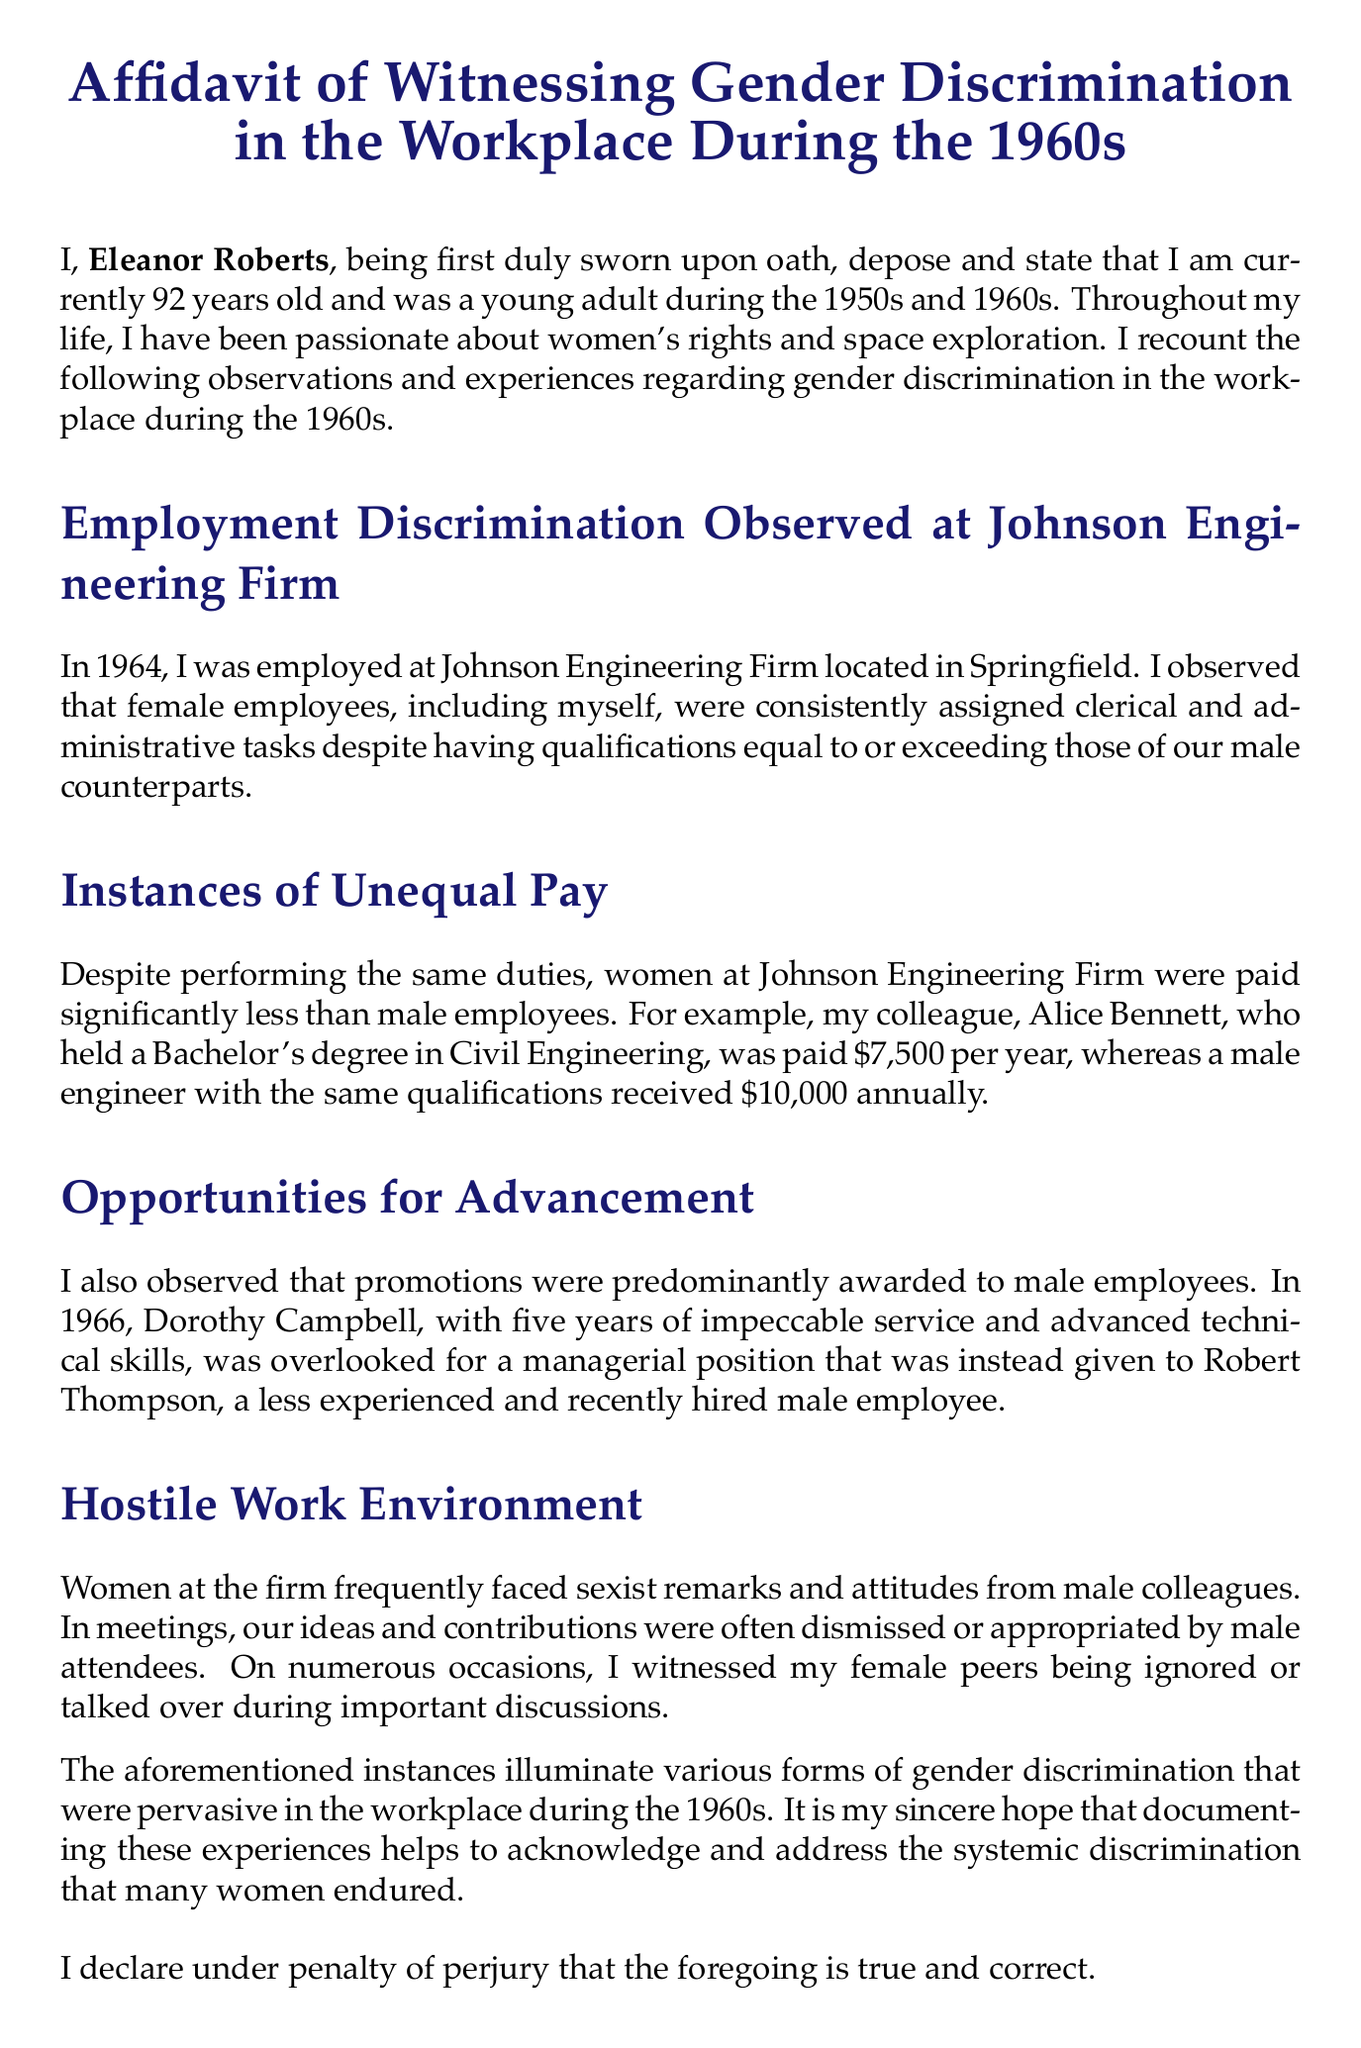what is the name of the witness? The document states the name of the witness is Eleanor Roberts.
Answer: Eleanor Roberts what year did Eleanor Roberts observe employment discrimination? The document mentions that employment discrimination was observed in 1964.
Answer: 1964 how much was Alice Bennett's salary per year? The document specifies that Alice Bennett was paid $7,500 per year.
Answer: $7,500 who was overlooked for the managerial position? The document states that Dorothy Campbell was overlooked for the managerial position.
Answer: Dorothy Campbell how many years of service did Dorothy Campbell have? The document indicates that Dorothy Campbell had five years of service.
Answer: five years what was the salary of the male engineer with equal qualifications? The document mentions that the male engineer received $10,000 annually.
Answer: $10,000 what type of environment did women face at the workplace? The document describes the work environment as hostile.
Answer: hostile what is the date of the affidavit? The document states that the date of the affidavit is October 2, 2023.
Answer: October 2, 2023 what is Eleanor Roberts' date of birth? The document provides Eleanor Roberts' date of birth as February 15, 1931.
Answer: February 15, 1931 